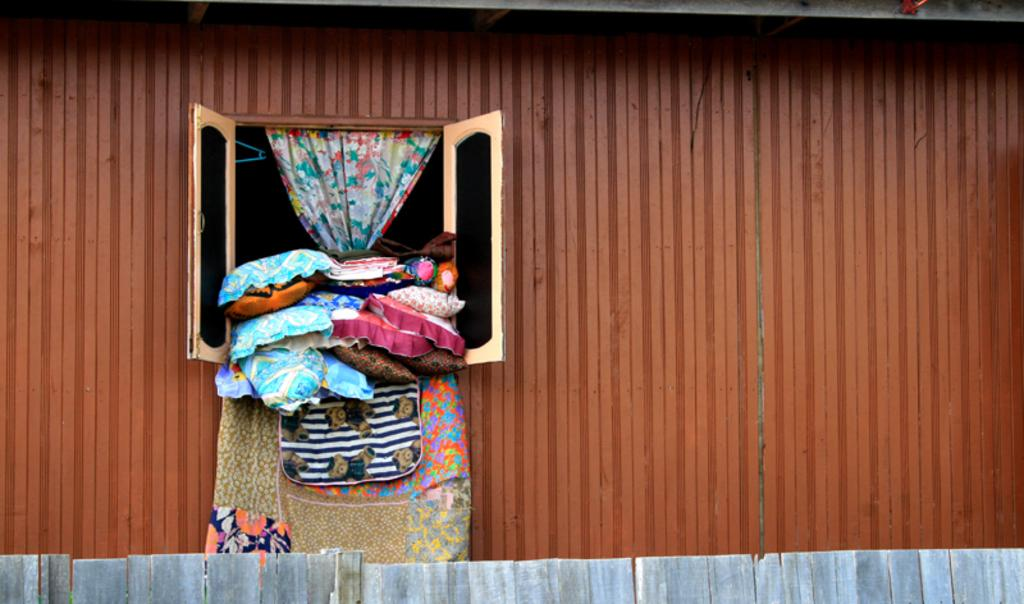What type of structure is visible through the window in the image? There is a window to a shed in the image. What type of soft furnishings can be seen in the image? There are pillows in the image. What type of personal items are visible in the image? There are clothes in the image. What type of window treatment is present in the image? There is a curtain in the image. What type of barrier is visible at the bottom of the image? There is a fence at the bottom of the image. What type of bulb is used to light up the shed in the image? There is no information about lighting in the shed in the image, so we cannot determine the type of bulb used. How does the fence roll along the bottom of the image? The fence does not roll along the bottom of the image; it is stationary. 